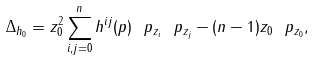<formula> <loc_0><loc_0><loc_500><loc_500>\Delta _ { h _ { 0 } } = z _ { 0 } ^ { 2 } \sum _ { i , j = 0 } ^ { n } h ^ { i j } ( p ) \ p _ { z _ { i } } \ p _ { z _ { j } } - ( n - 1 ) z _ { 0 } \ p _ { z _ { 0 } } ,</formula> 